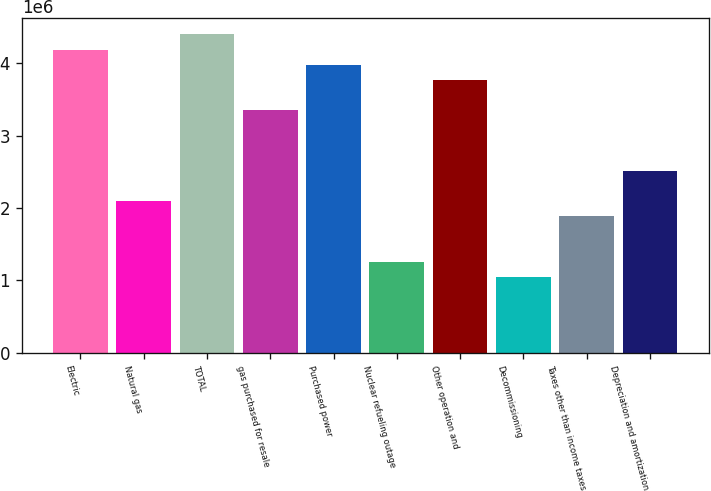<chart> <loc_0><loc_0><loc_500><loc_500><bar_chart><fcel>Electric<fcel>Natural gas<fcel>TOTAL<fcel>gas purchased for resale<fcel>Purchased power<fcel>Nuclear refueling outage<fcel>Other operation and<fcel>Decommissioning<fcel>Taxes other than income taxes<fcel>Depreciation and amortization<nl><fcel>4.19322e+06<fcel>2.09702e+06<fcel>4.40283e+06<fcel>3.35474e+06<fcel>3.9836e+06<fcel>1.25854e+06<fcel>3.77398e+06<fcel>1.04892e+06<fcel>1.8874e+06<fcel>2.51626e+06<nl></chart> 